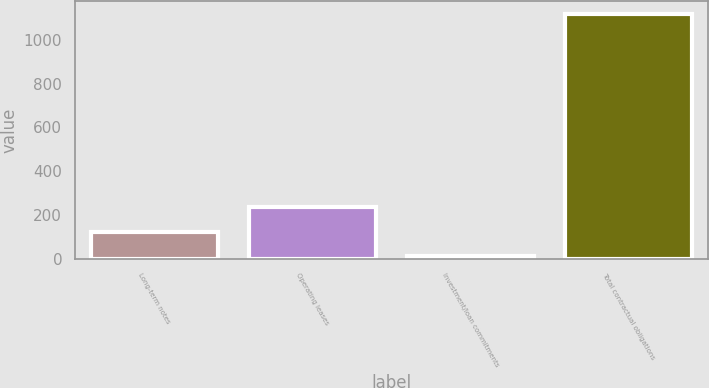Convert chart to OTSL. <chart><loc_0><loc_0><loc_500><loc_500><bar_chart><fcel>Long-term notes<fcel>Operating leases<fcel>Investment/loan commitments<fcel>Total contractual obligations<nl><fcel>126.2<fcel>236.4<fcel>16<fcel>1118<nl></chart> 